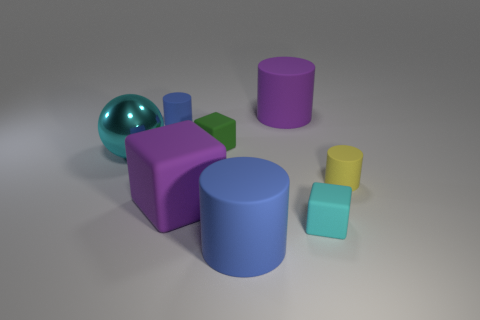Subtract all purple blocks. How many blocks are left? 2 Subtract all yellow balls. How many blue cylinders are left? 2 Subtract all yellow cylinders. How many cylinders are left? 3 Subtract 1 cylinders. How many cylinders are left? 3 Add 2 matte cylinders. How many objects exist? 10 Subtract all red cylinders. Subtract all green blocks. How many cylinders are left? 4 Subtract all cubes. How many objects are left? 5 Add 6 cyan matte things. How many cyan matte things are left? 7 Add 5 brown metal things. How many brown metal things exist? 5 Subtract 0 green cylinders. How many objects are left? 8 